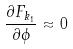<formula> <loc_0><loc_0><loc_500><loc_500>\frac { \partial F _ { k _ { 1 } } } { \partial \phi } \approx 0</formula> 